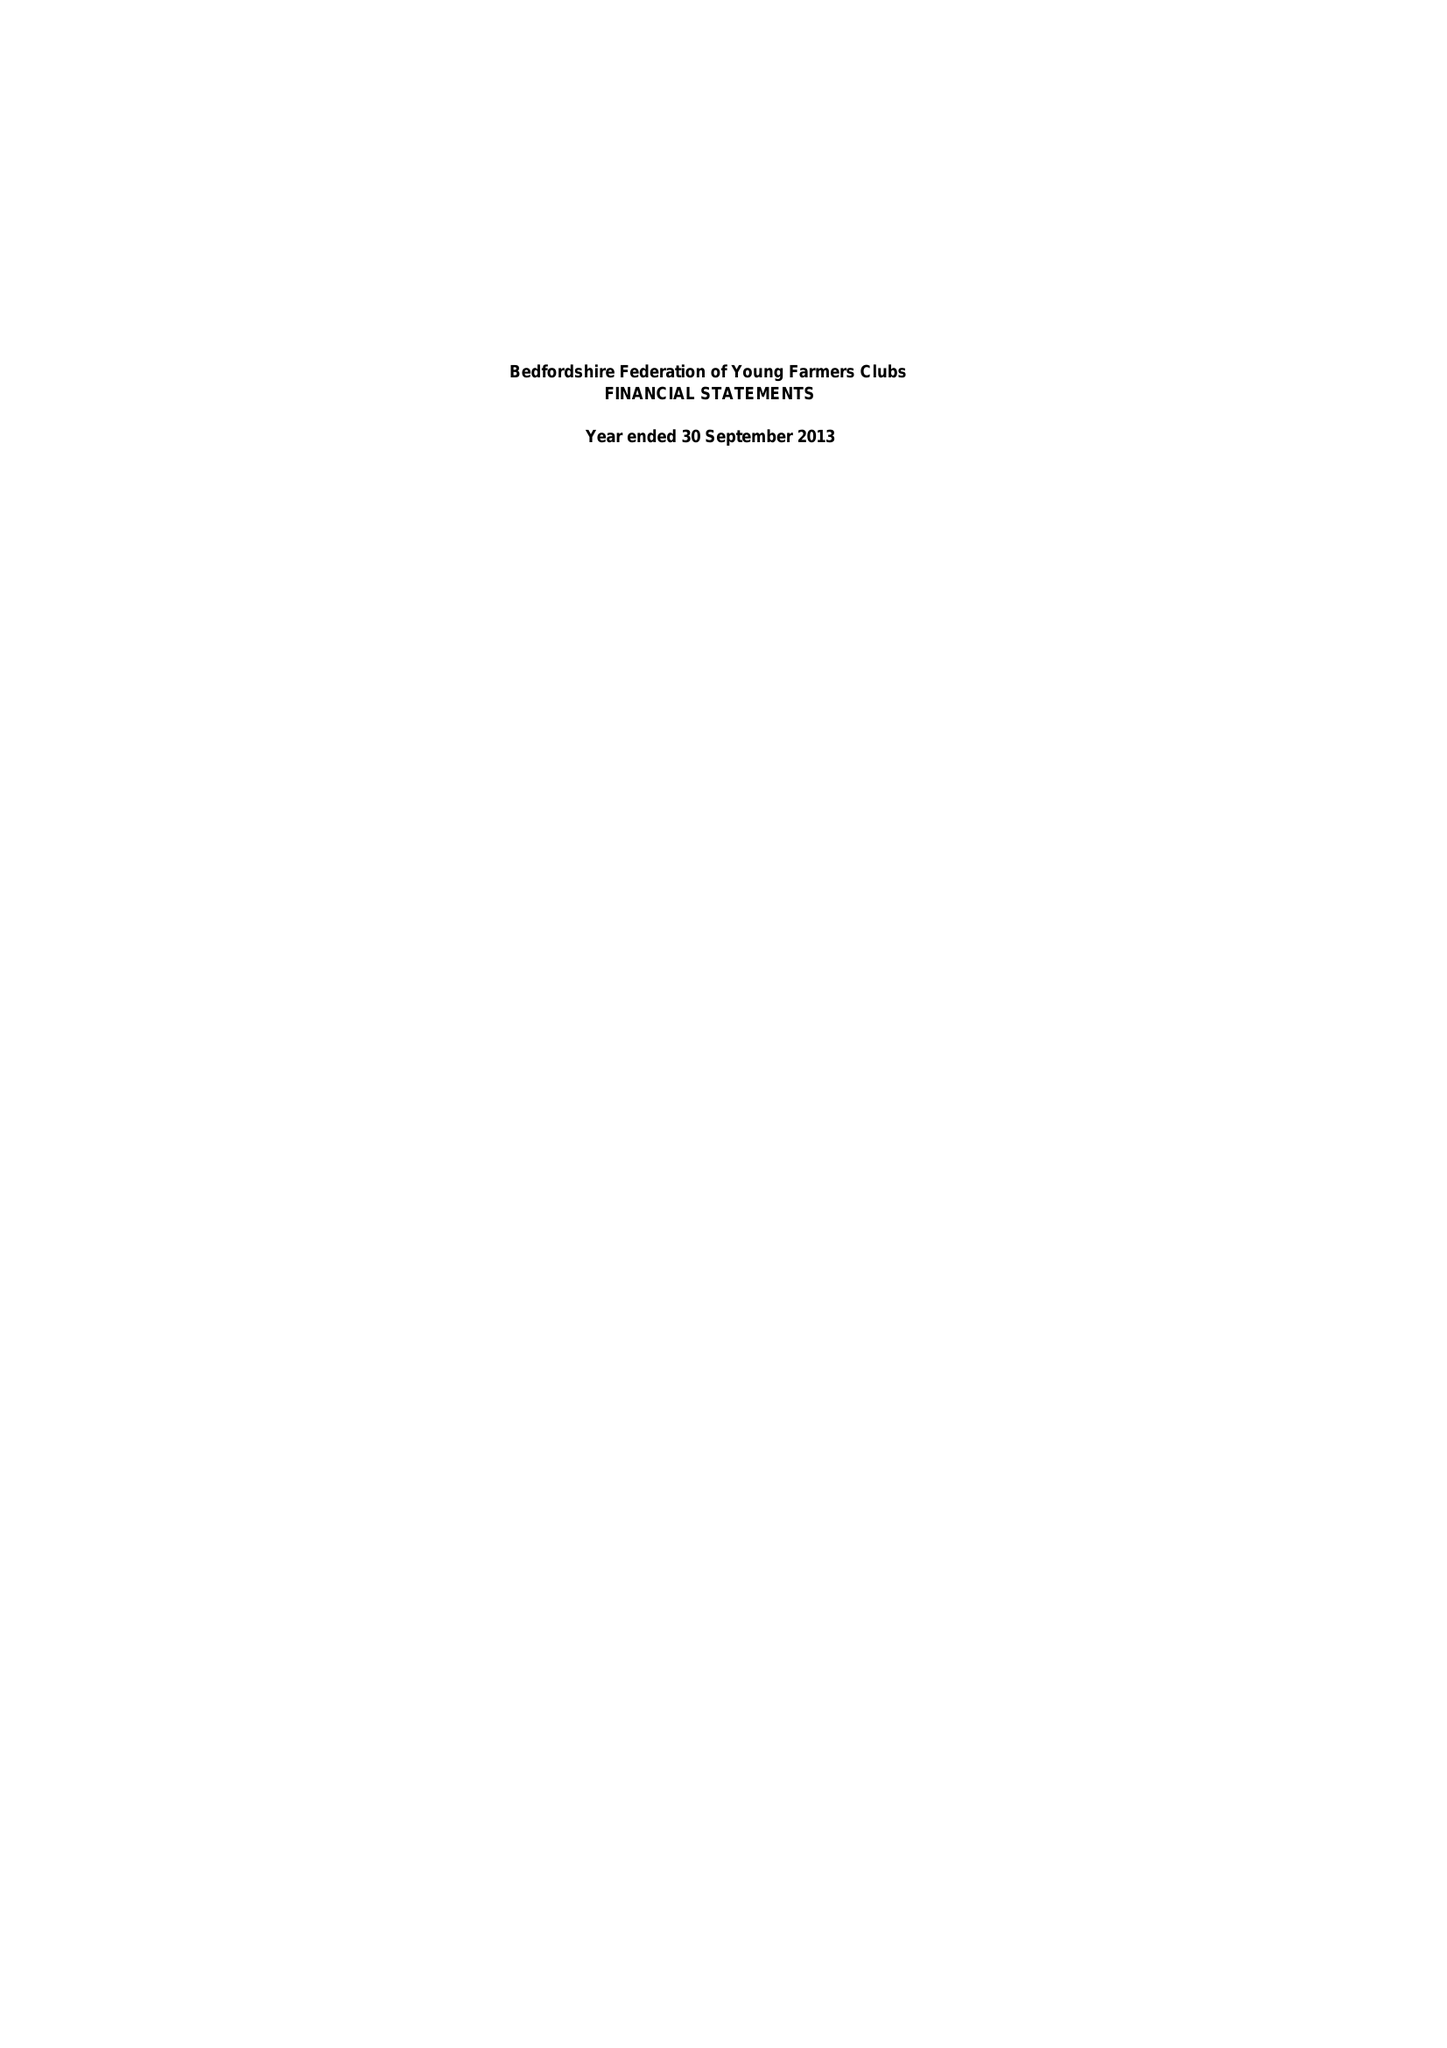What is the value for the address__post_town?
Answer the question using a single word or phrase. None 